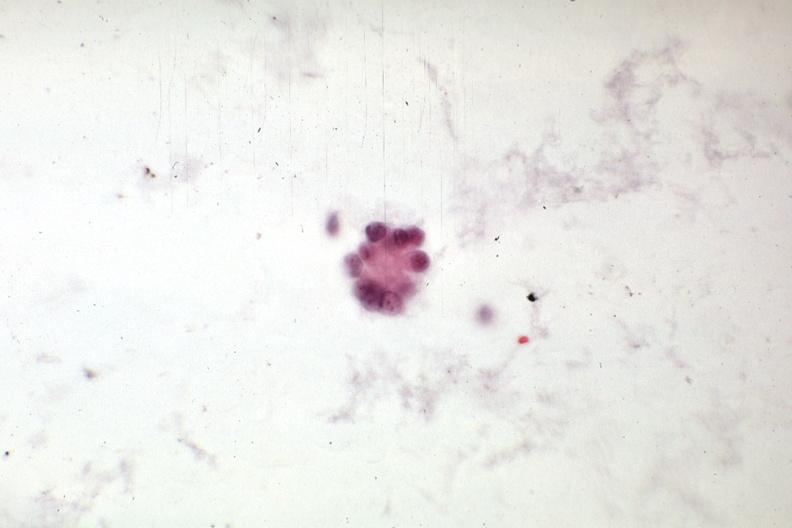what is present?
Answer the question using a single word or phrase. Carcinoma 